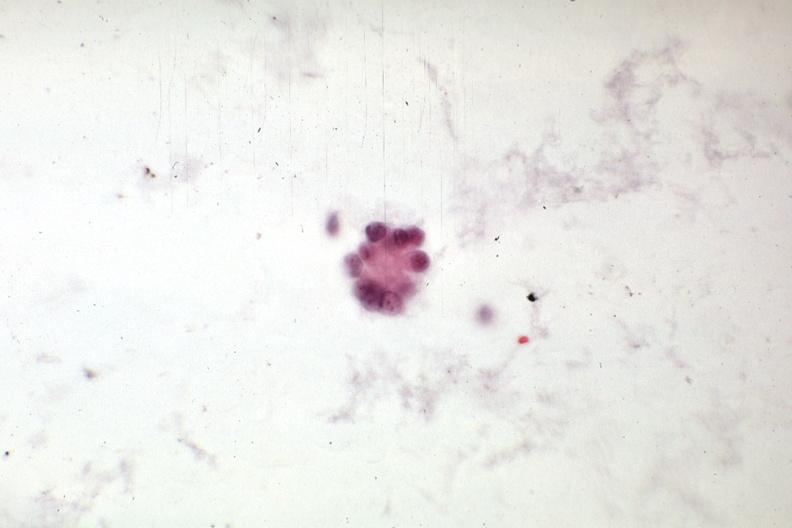what is present?
Answer the question using a single word or phrase. Carcinoma 